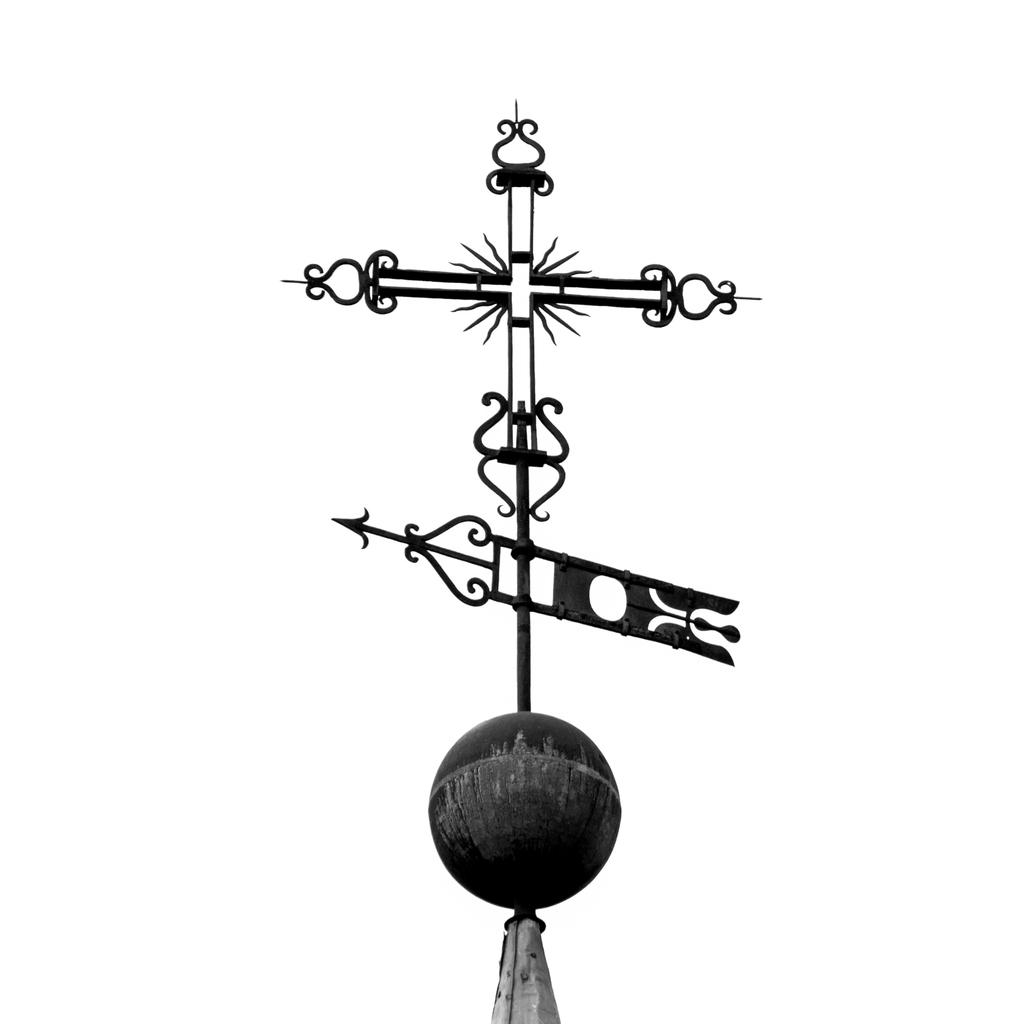What object is located at the bottom of the image? There is a ball at the bottom of the image. What type of object is at the top of the image? There is a pointer direction made up of metal at the top of the image. How many women are holding forks in the image? There are no women or forks present in the image. What type of creature is the scarecrow interacting with in the image? There is no scarecrow present in the image. 